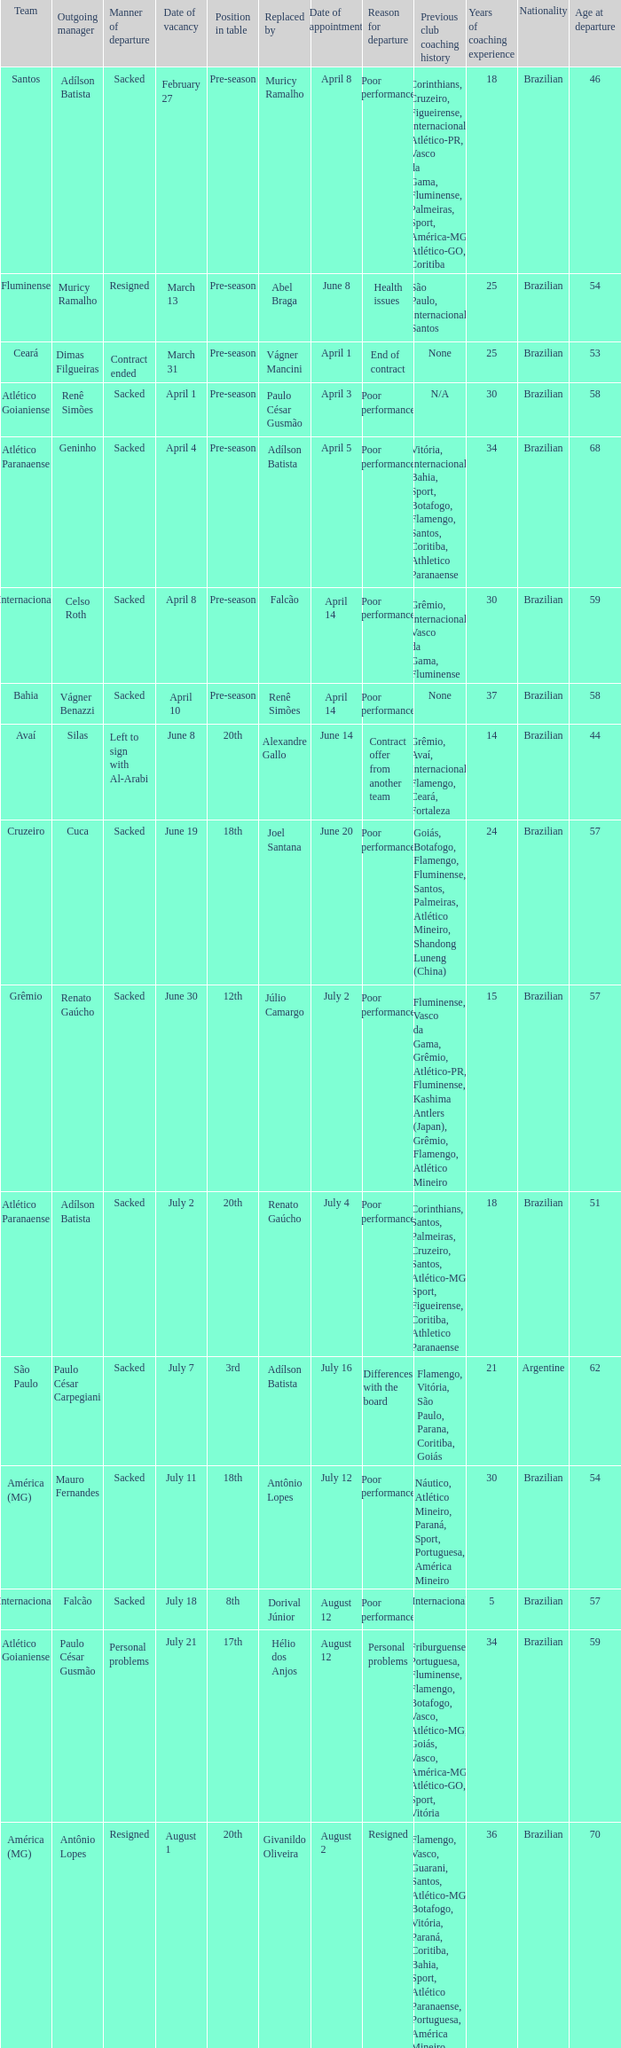Why did Geninho leave as manager? Sacked. 